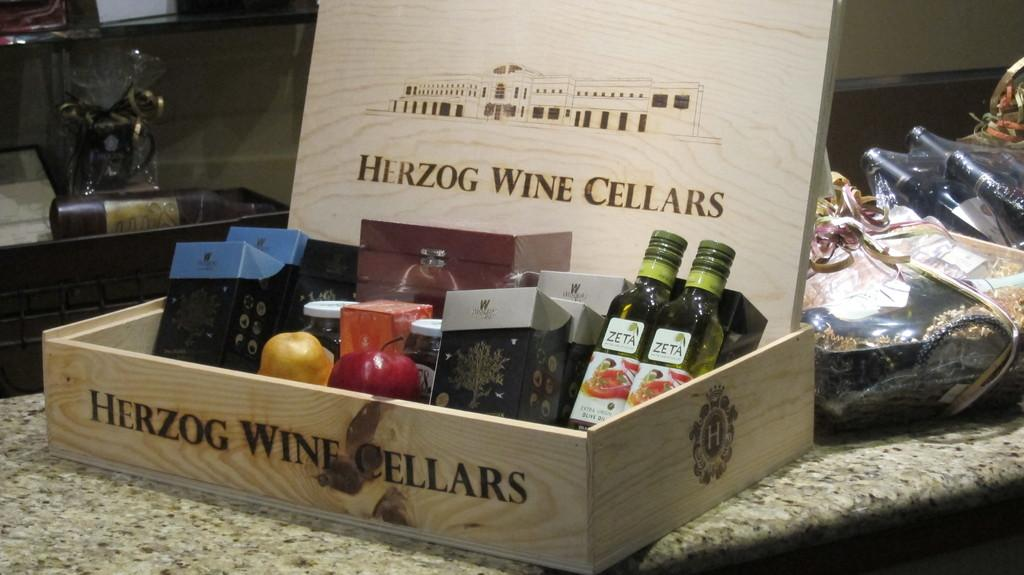<image>
Offer a succinct explanation of the picture presented. An assorted gifts in a wooden box, stamped Herzog Wine Cellars 